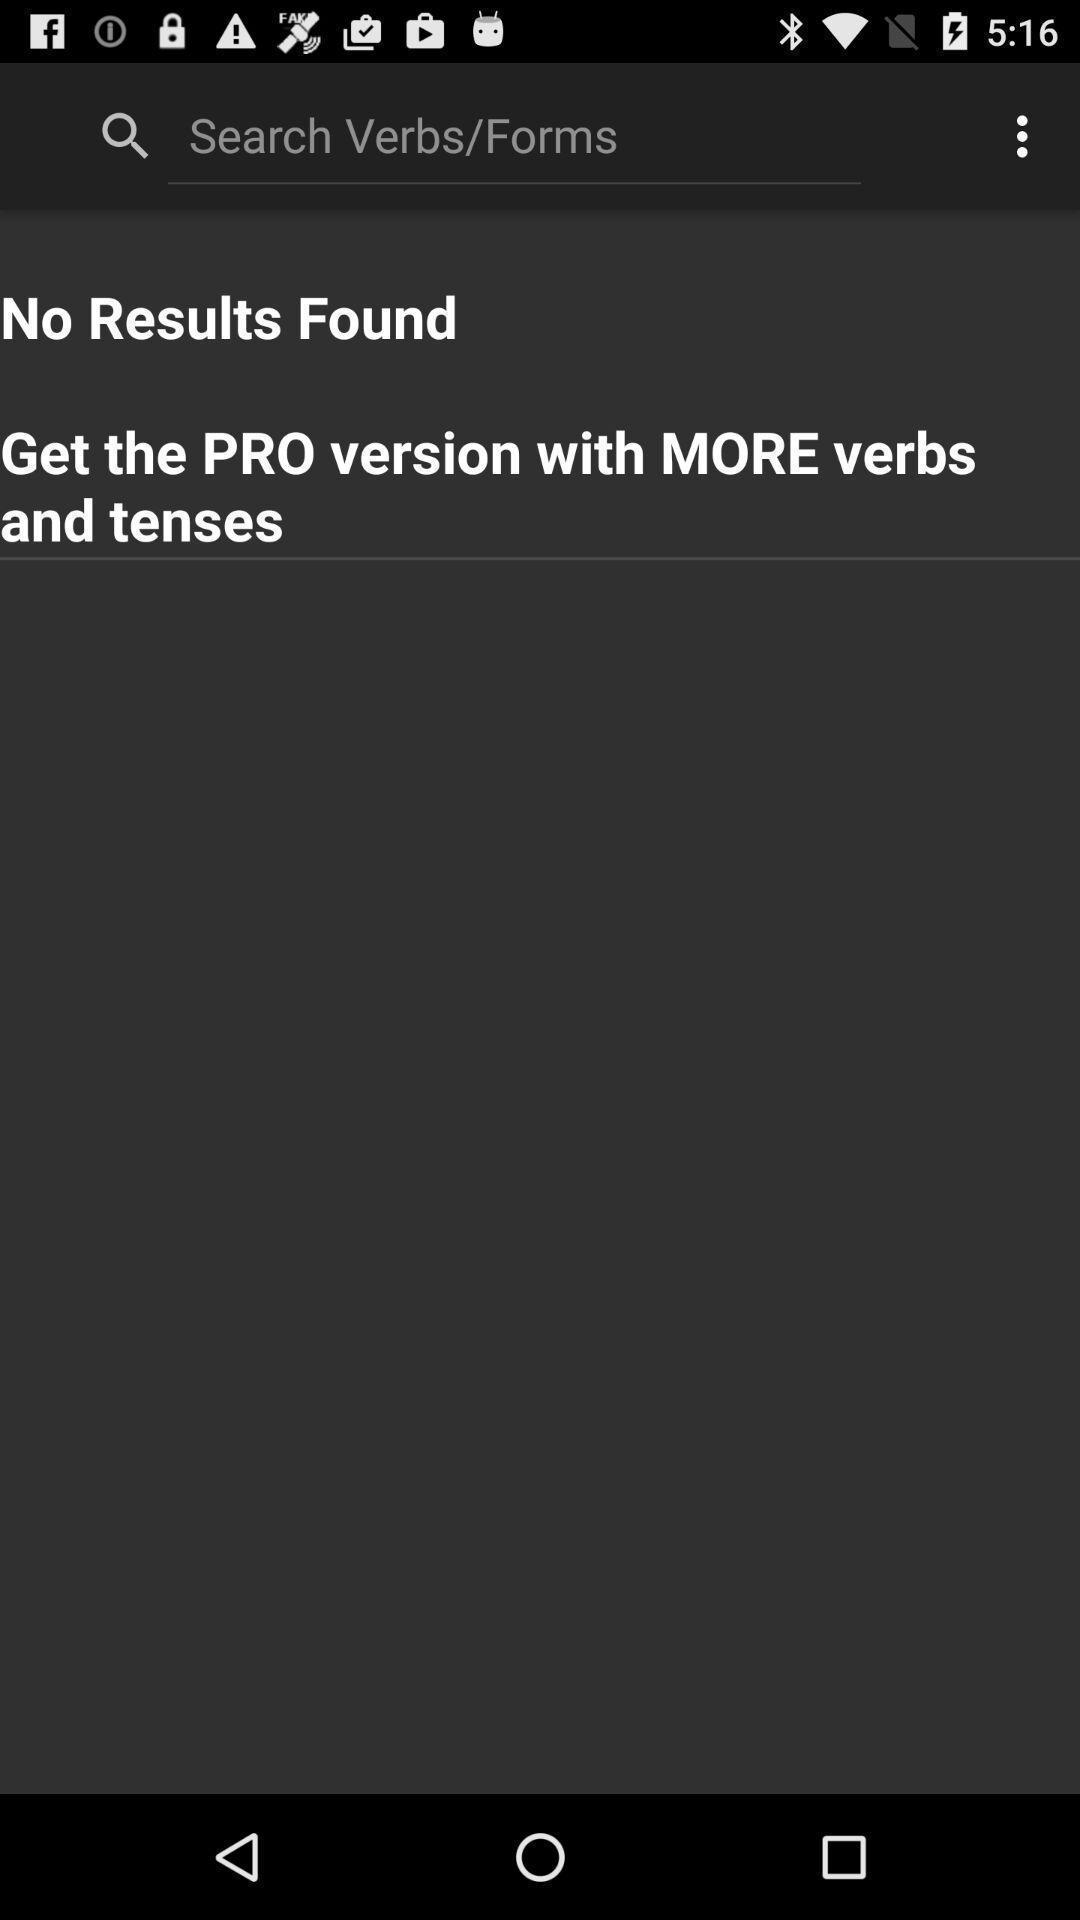Describe the visual elements of this screenshot. Search page to find words in learning application. 